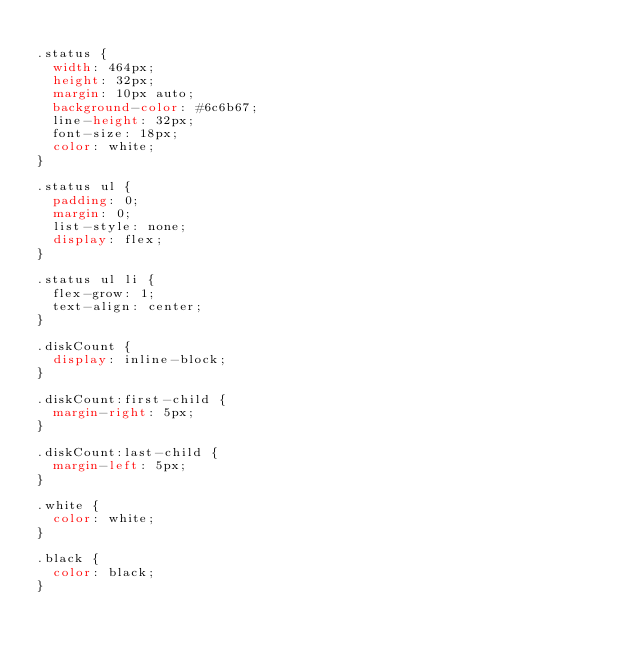<code> <loc_0><loc_0><loc_500><loc_500><_CSS_>
.status {
  width: 464px;
  height: 32px;
  margin: 10px auto;
  background-color: #6c6b67;
  line-height: 32px;
  font-size: 18px;
  color: white;
}

.status ul {
  padding: 0;
  margin: 0;
  list-style: none;
  display: flex;
}

.status ul li {
  flex-grow: 1;
  text-align: center;
}

.diskCount {
  display: inline-block;
}

.diskCount:first-child {
  margin-right: 5px;
}

.diskCount:last-child {
  margin-left: 5px;
}

.white {
  color: white;
}

.black {
  color: black;
}
</code> 